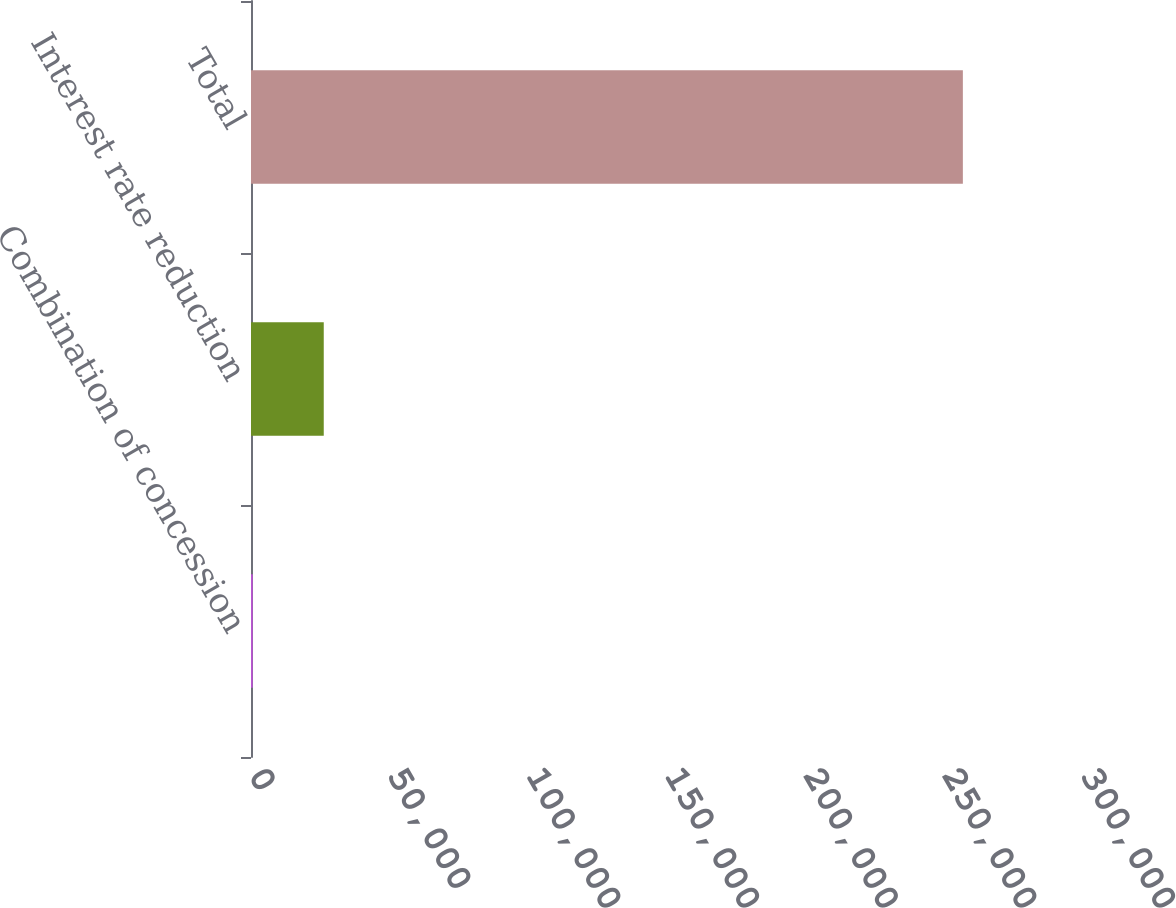Convert chart. <chart><loc_0><loc_0><loc_500><loc_500><bar_chart><fcel>Combination of concession<fcel>Interest rate reduction<fcel>Total<nl><fcel>628<fcel>26233.3<fcel>256681<nl></chart> 